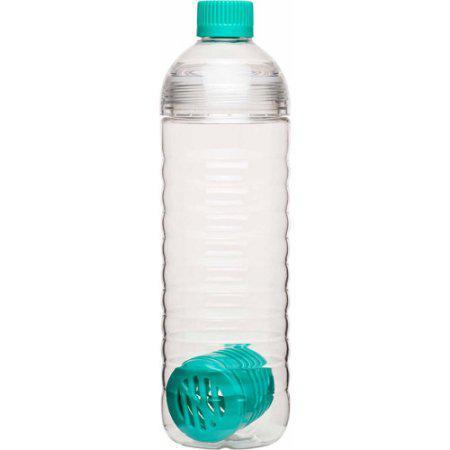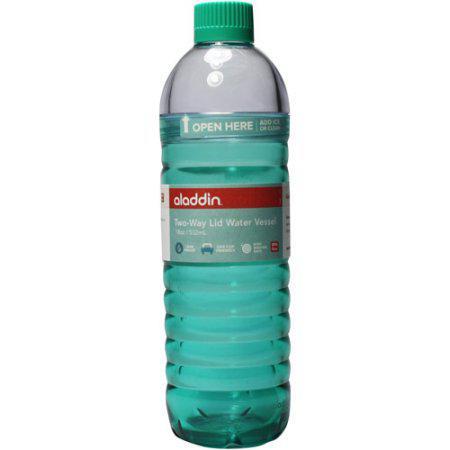The first image is the image on the left, the second image is the image on the right. For the images displayed, is the sentence "One bottle is filled with colored liquid and the other is filled with clear liquid." factually correct? Answer yes or no. Yes. The first image is the image on the left, the second image is the image on the right. For the images shown, is this caption "An image shows a clear water bottle containing a solid-colored perforated cylindrical item inside at the bottom." true? Answer yes or no. Yes. 